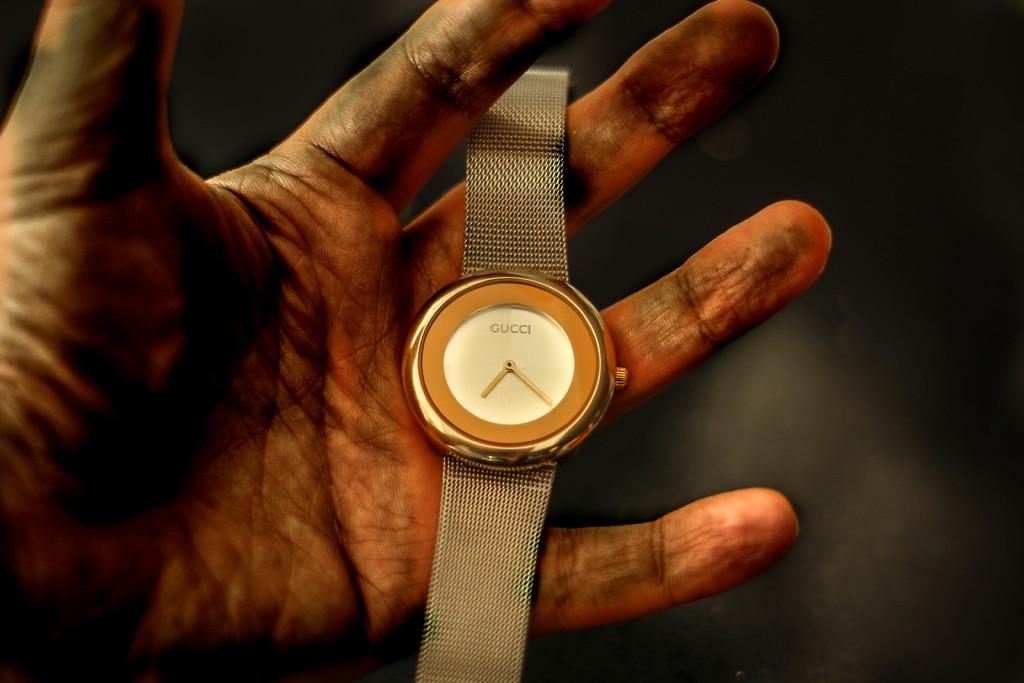What time is it?
Provide a short and direct response. 7:20. 